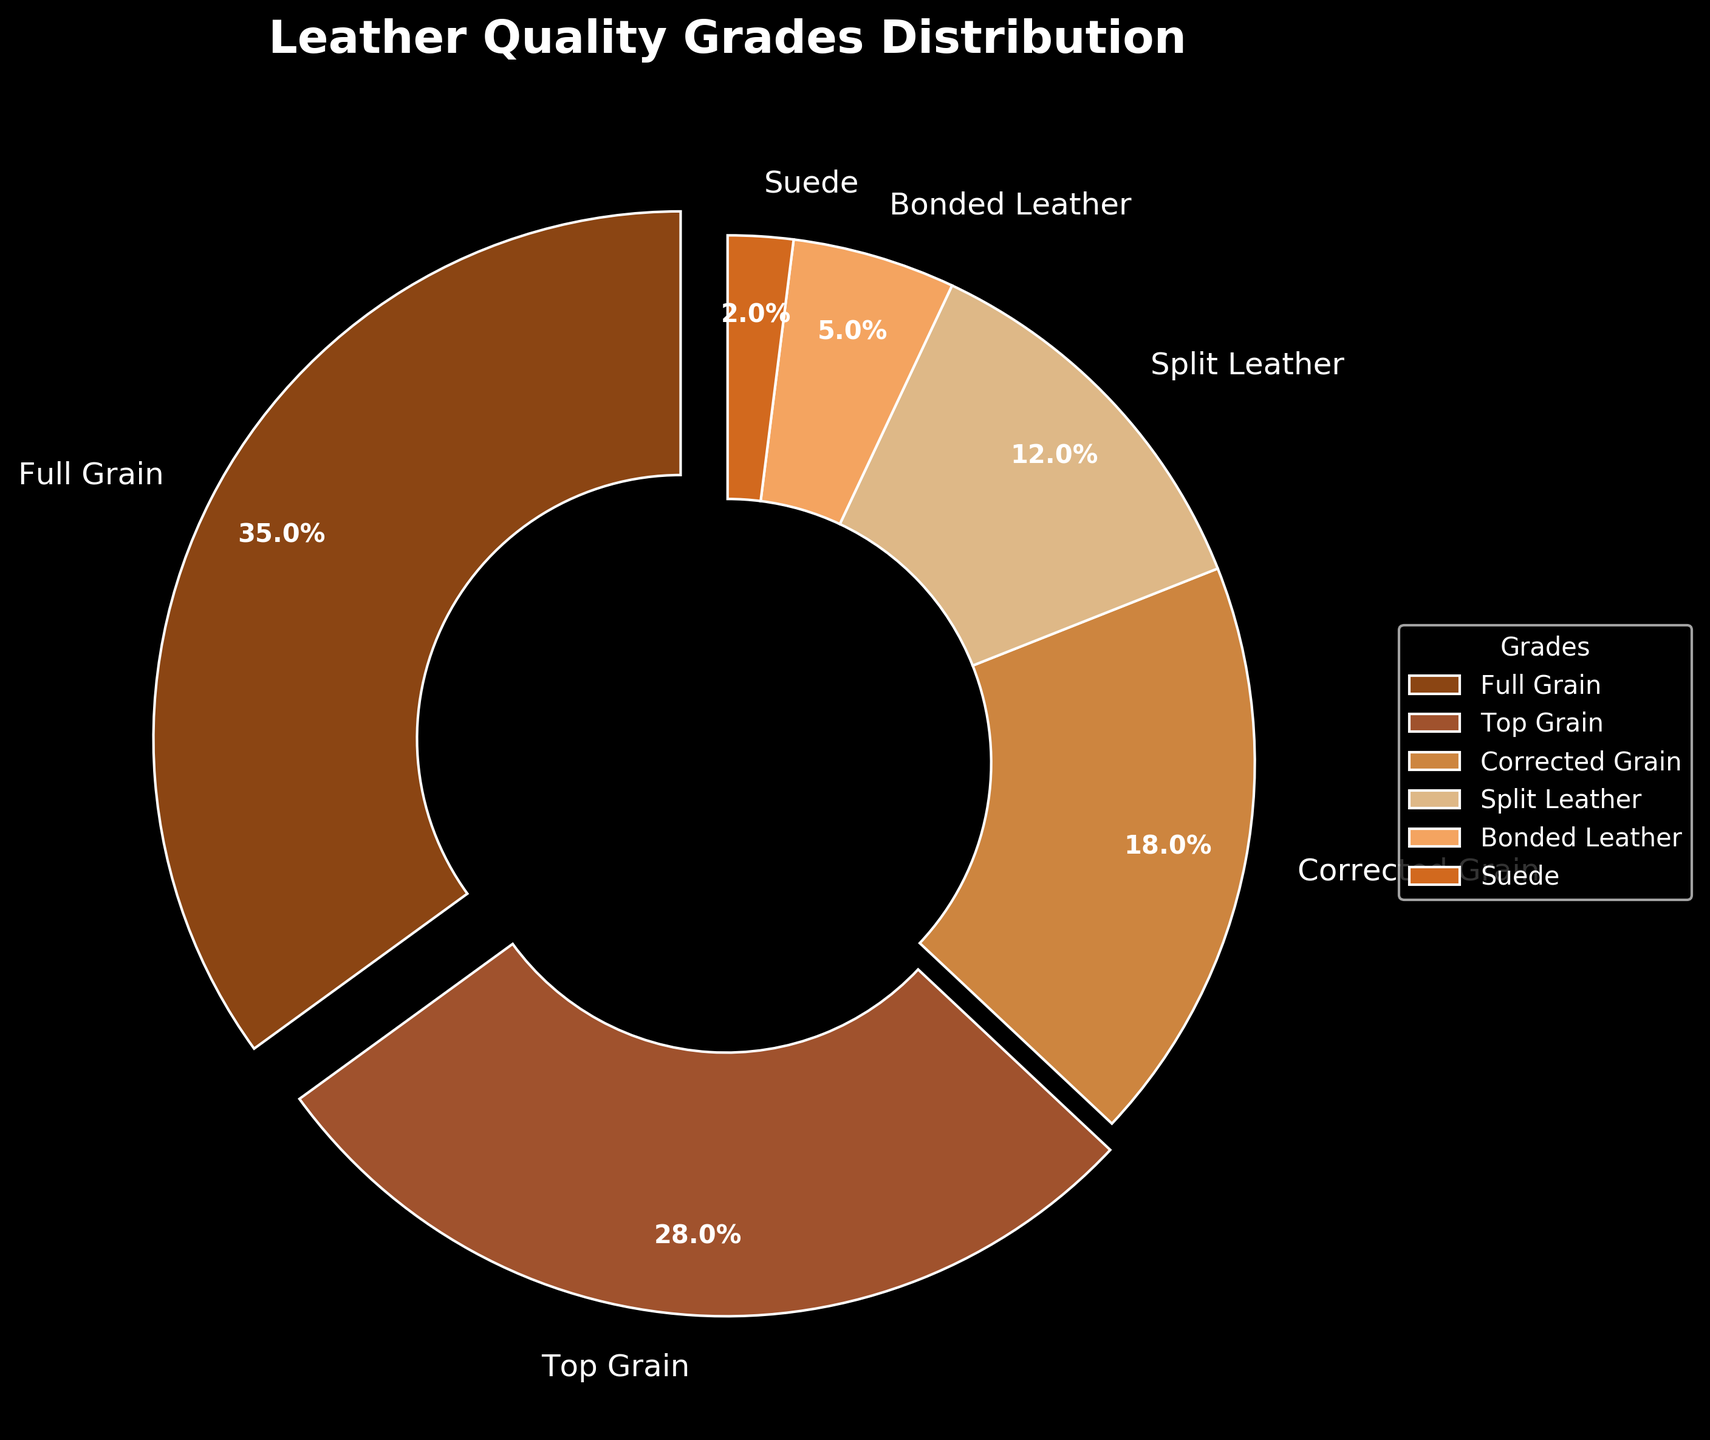Which grade of leather has the largest percentage in the distribution? To determine the largest percentage, look at the pie chart and identify the segment with the highest percentage label. Full Grain leather is labeled as 35%, which is the highest percentage in the chart.
Answer: Full Grain What is the combined percentage of Corrected Grain and Split Leather? Sum the percentages of Corrected Grain (18%) and Split Leather (12%). 18% + 12% equals 30%.
Answer: 30% How does the percentage of Bonded Leather compare to Suede? Bonded Leather is shown as 5%, while Suede is 2%. Bonded Leather has a higher percentage.
Answer: Bonded Leather has a higher percentage What are the colors representing each leather grade in the pie chart? Each segment of the pie chart is colored differently: Full Grain is brown, Top Grain is tan, Corrected Grain is light brown, Split Leather is beige, Bonded Leather is light orange, and Suede is orange.
Answer: Full Grain: brown, Top Grain: tan, Corrected Grain: light brown, Split Leather: beige, Bonded Leather: light orange, Suede: orange Which leather grades make up more than 50% of the total distribution when combined? Identify the leather grades and their percentages: Full Grain (35%), Top Grain (28%), Corrected Grain (18%), Split Leather (12%), Bonded Leather (5%), Suede (2%). Adding the two highest percentages—Full Grain and Top Grain—results in 35% + 28% = 63%, which is more than 50%.
Answer: Full Grain and Top Grain What is the total percentage represented by leather grades classified as Split Leather, Bonded Leather, and Suede? Add the percentages of Split Leather (12%), Bonded Leather (5%), and Suede (2%). 12% + 5% + 2% equals 19%.
Answer: 19% Which leather grade has the least representation in the distribution? Look at the smallest percentage on the pie chart. Suede has the lowest percentage labeled as 2%.
Answer: Suede What is the difference in percentage between Full Grain and Top Grain leather grades? Subtract the percentage of Top Grain (28%) from Full Grain (35%). 35% - 28% equals 7%.
Answer: 7% Is the combined percentage of Split Leather and Bonded Leather greater than that of Corrected Grain? First, sum the percentages of Split Leather (12%) and Bonded Leather (5%) which is 12% + 5% = 17%. Next, compare it to Corrected Grain (18%). Since 17% is less than 18%, the combined percentage is not greater.
Answer: No 